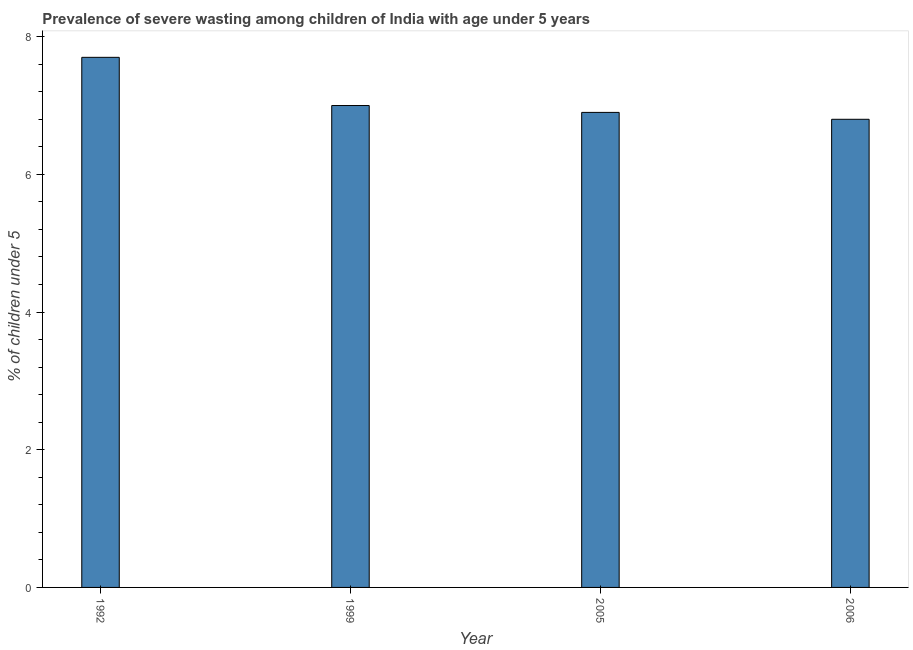What is the title of the graph?
Provide a succinct answer. Prevalence of severe wasting among children of India with age under 5 years. What is the label or title of the X-axis?
Your answer should be very brief. Year. What is the label or title of the Y-axis?
Your answer should be compact.  % of children under 5. What is the prevalence of severe wasting in 2005?
Offer a very short reply. 6.9. Across all years, what is the maximum prevalence of severe wasting?
Give a very brief answer. 7.7. Across all years, what is the minimum prevalence of severe wasting?
Give a very brief answer. 6.8. What is the sum of the prevalence of severe wasting?
Offer a terse response. 28.4. What is the difference between the prevalence of severe wasting in 1992 and 2006?
Offer a terse response. 0.9. What is the average prevalence of severe wasting per year?
Provide a succinct answer. 7.1. What is the median prevalence of severe wasting?
Give a very brief answer. 6.95. Do a majority of the years between 1999 and 2006 (inclusive) have prevalence of severe wasting greater than 0.4 %?
Give a very brief answer. Yes. What is the ratio of the prevalence of severe wasting in 1992 to that in 2005?
Offer a very short reply. 1.12. What is the difference between the highest and the lowest prevalence of severe wasting?
Your answer should be very brief. 0.9. How many bars are there?
Your answer should be very brief. 4. Are all the bars in the graph horizontal?
Your answer should be very brief. No. What is the difference between two consecutive major ticks on the Y-axis?
Offer a terse response. 2. Are the values on the major ticks of Y-axis written in scientific E-notation?
Your answer should be compact. No. What is the  % of children under 5 in 1992?
Give a very brief answer. 7.7. What is the  % of children under 5 in 2005?
Offer a terse response. 6.9. What is the  % of children under 5 of 2006?
Provide a succinct answer. 6.8. What is the difference between the  % of children under 5 in 1992 and 1999?
Your answer should be compact. 0.7. What is the difference between the  % of children under 5 in 1992 and 2006?
Your answer should be very brief. 0.9. What is the difference between the  % of children under 5 in 2005 and 2006?
Offer a very short reply. 0.1. What is the ratio of the  % of children under 5 in 1992 to that in 2005?
Provide a succinct answer. 1.12. What is the ratio of the  % of children under 5 in 1992 to that in 2006?
Provide a succinct answer. 1.13. What is the ratio of the  % of children under 5 in 1999 to that in 2005?
Your answer should be compact. 1.01. What is the ratio of the  % of children under 5 in 2005 to that in 2006?
Offer a very short reply. 1.01. 